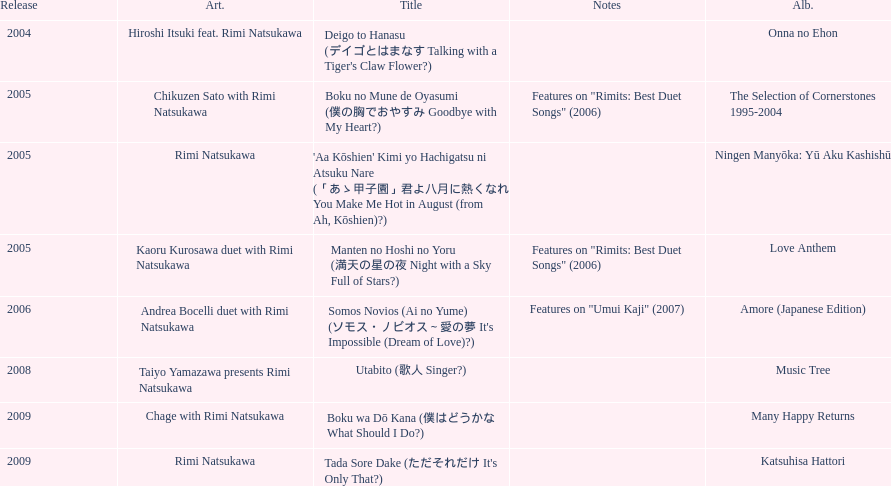What is the last title released? 2009. 